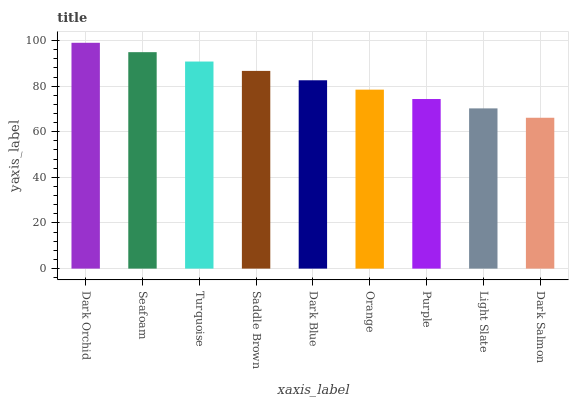Is Dark Salmon the minimum?
Answer yes or no. Yes. Is Dark Orchid the maximum?
Answer yes or no. Yes. Is Seafoam the minimum?
Answer yes or no. No. Is Seafoam the maximum?
Answer yes or no. No. Is Dark Orchid greater than Seafoam?
Answer yes or no. Yes. Is Seafoam less than Dark Orchid?
Answer yes or no. Yes. Is Seafoam greater than Dark Orchid?
Answer yes or no. No. Is Dark Orchid less than Seafoam?
Answer yes or no. No. Is Dark Blue the high median?
Answer yes or no. Yes. Is Dark Blue the low median?
Answer yes or no. Yes. Is Turquoise the high median?
Answer yes or no. No. Is Purple the low median?
Answer yes or no. No. 